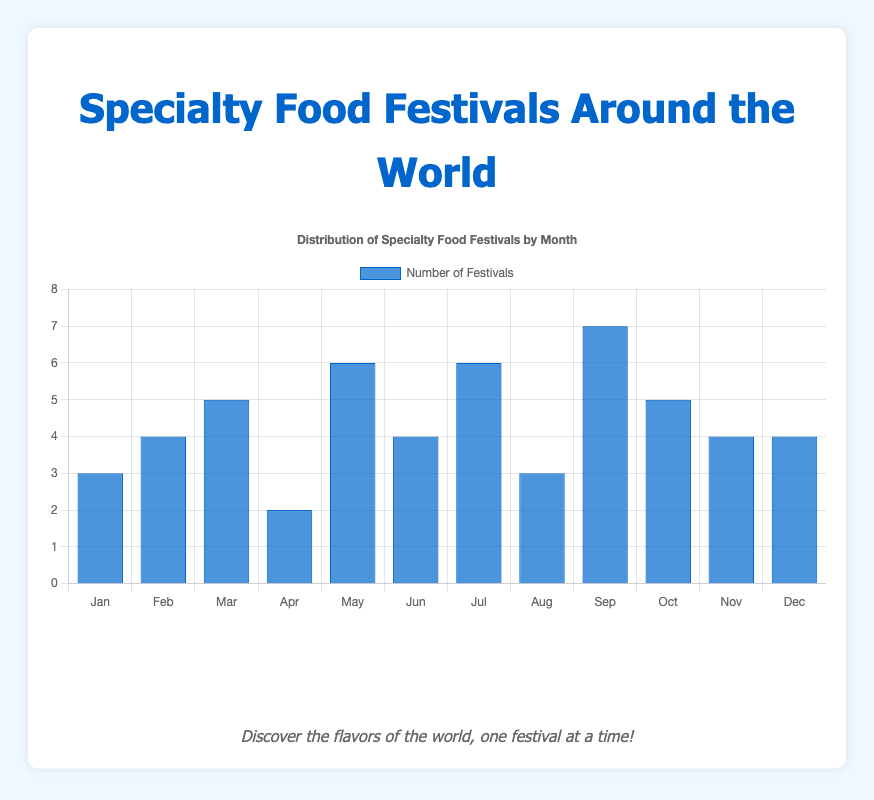How many festivals are there in January and February combined? To find the combined total, sum the number of festivals in January (3) and February (4). 3 + 4 = 7
Answer: 7 Which month has the most specialty food festivals? Identify the bar with the greatest height. September has the tallest bar, indicating the highest count of 7 festivals.
Answer: September Are there more festivals in the second half of the year (July to December) compared to the first half (January to June)? Sum the number of festivals from July to December (6 + 3 + 7 + 5 + 4 + 4 = 29) and from January to June (3 + 4 + 5 + 2 + 6 + 4 = 24). The second half has 29 festivals, and the first half has 24.
Answer: Yes What is the difference in the number of festivals between the month with the most festivals and the month with the fewest festivals? The month with the most festivals is September (7 festivals), and the month with the fewest is April (2 festivals). The difference is 7 - 2 = 5.
Answer: 5 What is the average number of festivals per month across the year? Sum the total number of festivals for all months (3 + 4 + 5 + 2 + 6 + 4 + 6 + 3 + 7 + 5 + 4 + 4 = 53) and divide by 12 months. The average is 53 / 12 ≈ 4.42.
Answer: 4.42 Which months have the same number of festivals? Look for bars of equal height. February, June, November, and December all have bars of the same height (4 festivals each).
Answer: February, June, November, December How does the number of festivals in August compare to that in October? Compare the heights of the bars for August (3) and October (5). October has 2 more festivals than August.
Answer: October has 2 more What is the total number of festivals in months with more than 4 festivals? Identify months with more than 4 festivals: March (5), May (6), July (6), September (7), October (5). Sum their counts: 5 + 6 + 6 + 7 + 5 = 29.
Answer: 29 What's the proportion of festivals held in May out of the total annual festivals? Count the number of festivals in May (6) and divide by the total number of festivals (53). The proportion is 6 / 53 ≈ 0.1132 or 11.32%.
Answer: 11.32% 